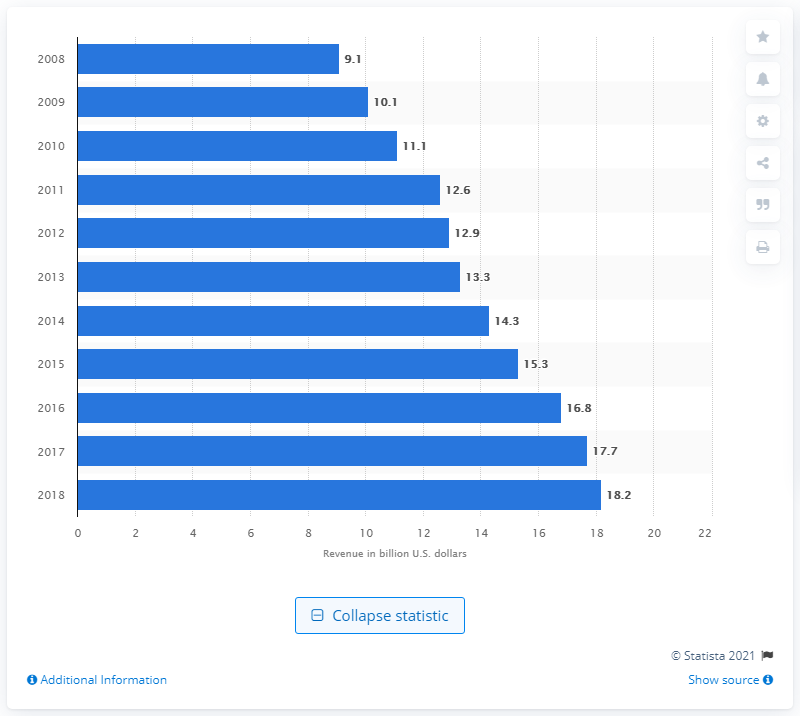Highlight a few significant elements in this photo. In 2016, the revenue generated by 3PLs in the healthcare market was 16.8 billion US dollars. 